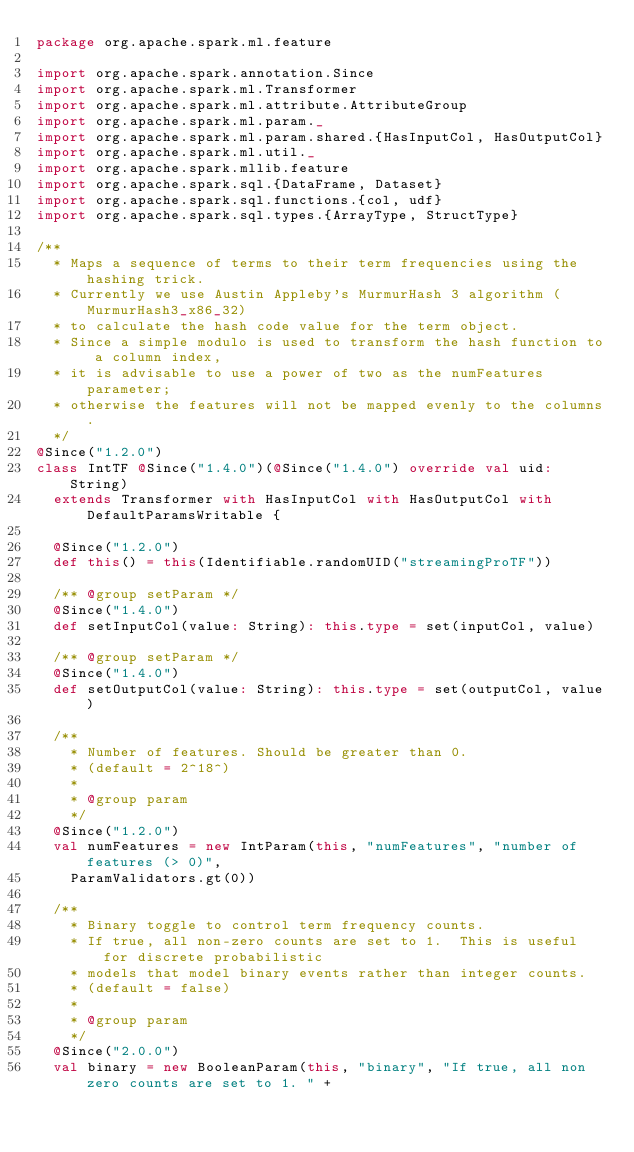Convert code to text. <code><loc_0><loc_0><loc_500><loc_500><_Scala_>package org.apache.spark.ml.feature

import org.apache.spark.annotation.Since
import org.apache.spark.ml.Transformer
import org.apache.spark.ml.attribute.AttributeGroup
import org.apache.spark.ml.param._
import org.apache.spark.ml.param.shared.{HasInputCol, HasOutputCol}
import org.apache.spark.ml.util._
import org.apache.spark.mllib.feature
import org.apache.spark.sql.{DataFrame, Dataset}
import org.apache.spark.sql.functions.{col, udf}
import org.apache.spark.sql.types.{ArrayType, StructType}

/**
  * Maps a sequence of terms to their term frequencies using the hashing trick.
  * Currently we use Austin Appleby's MurmurHash 3 algorithm (MurmurHash3_x86_32)
  * to calculate the hash code value for the term object.
  * Since a simple modulo is used to transform the hash function to a column index,
  * it is advisable to use a power of two as the numFeatures parameter;
  * otherwise the features will not be mapped evenly to the columns.
  */
@Since("1.2.0")
class IntTF @Since("1.4.0")(@Since("1.4.0") override val uid: String)
  extends Transformer with HasInputCol with HasOutputCol with DefaultParamsWritable {

  @Since("1.2.0")
  def this() = this(Identifiable.randomUID("streamingProTF"))

  /** @group setParam */
  @Since("1.4.0")
  def setInputCol(value: String): this.type = set(inputCol, value)

  /** @group setParam */
  @Since("1.4.0")
  def setOutputCol(value: String): this.type = set(outputCol, value)

  /**
    * Number of features. Should be greater than 0.
    * (default = 2^18^)
    *
    * @group param
    */
  @Since("1.2.0")
  val numFeatures = new IntParam(this, "numFeatures", "number of features (> 0)",
    ParamValidators.gt(0))

  /**
    * Binary toggle to control term frequency counts.
    * If true, all non-zero counts are set to 1.  This is useful for discrete probabilistic
    * models that model binary events rather than integer counts.
    * (default = false)
    *
    * @group param
    */
  @Since("2.0.0")
  val binary = new BooleanParam(this, "binary", "If true, all non zero counts are set to 1. " +</code> 